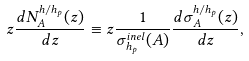<formula> <loc_0><loc_0><loc_500><loc_500>z \frac { d N ^ { h / h _ { p } } _ { A } ( z ) } { d z } \equiv z \frac { 1 } { \sigma ^ { i n e l } _ { h _ { p } } ( A ) } \frac { d \sigma _ { A } ^ { h / h _ { p } } ( z ) } { d z } ,</formula> 